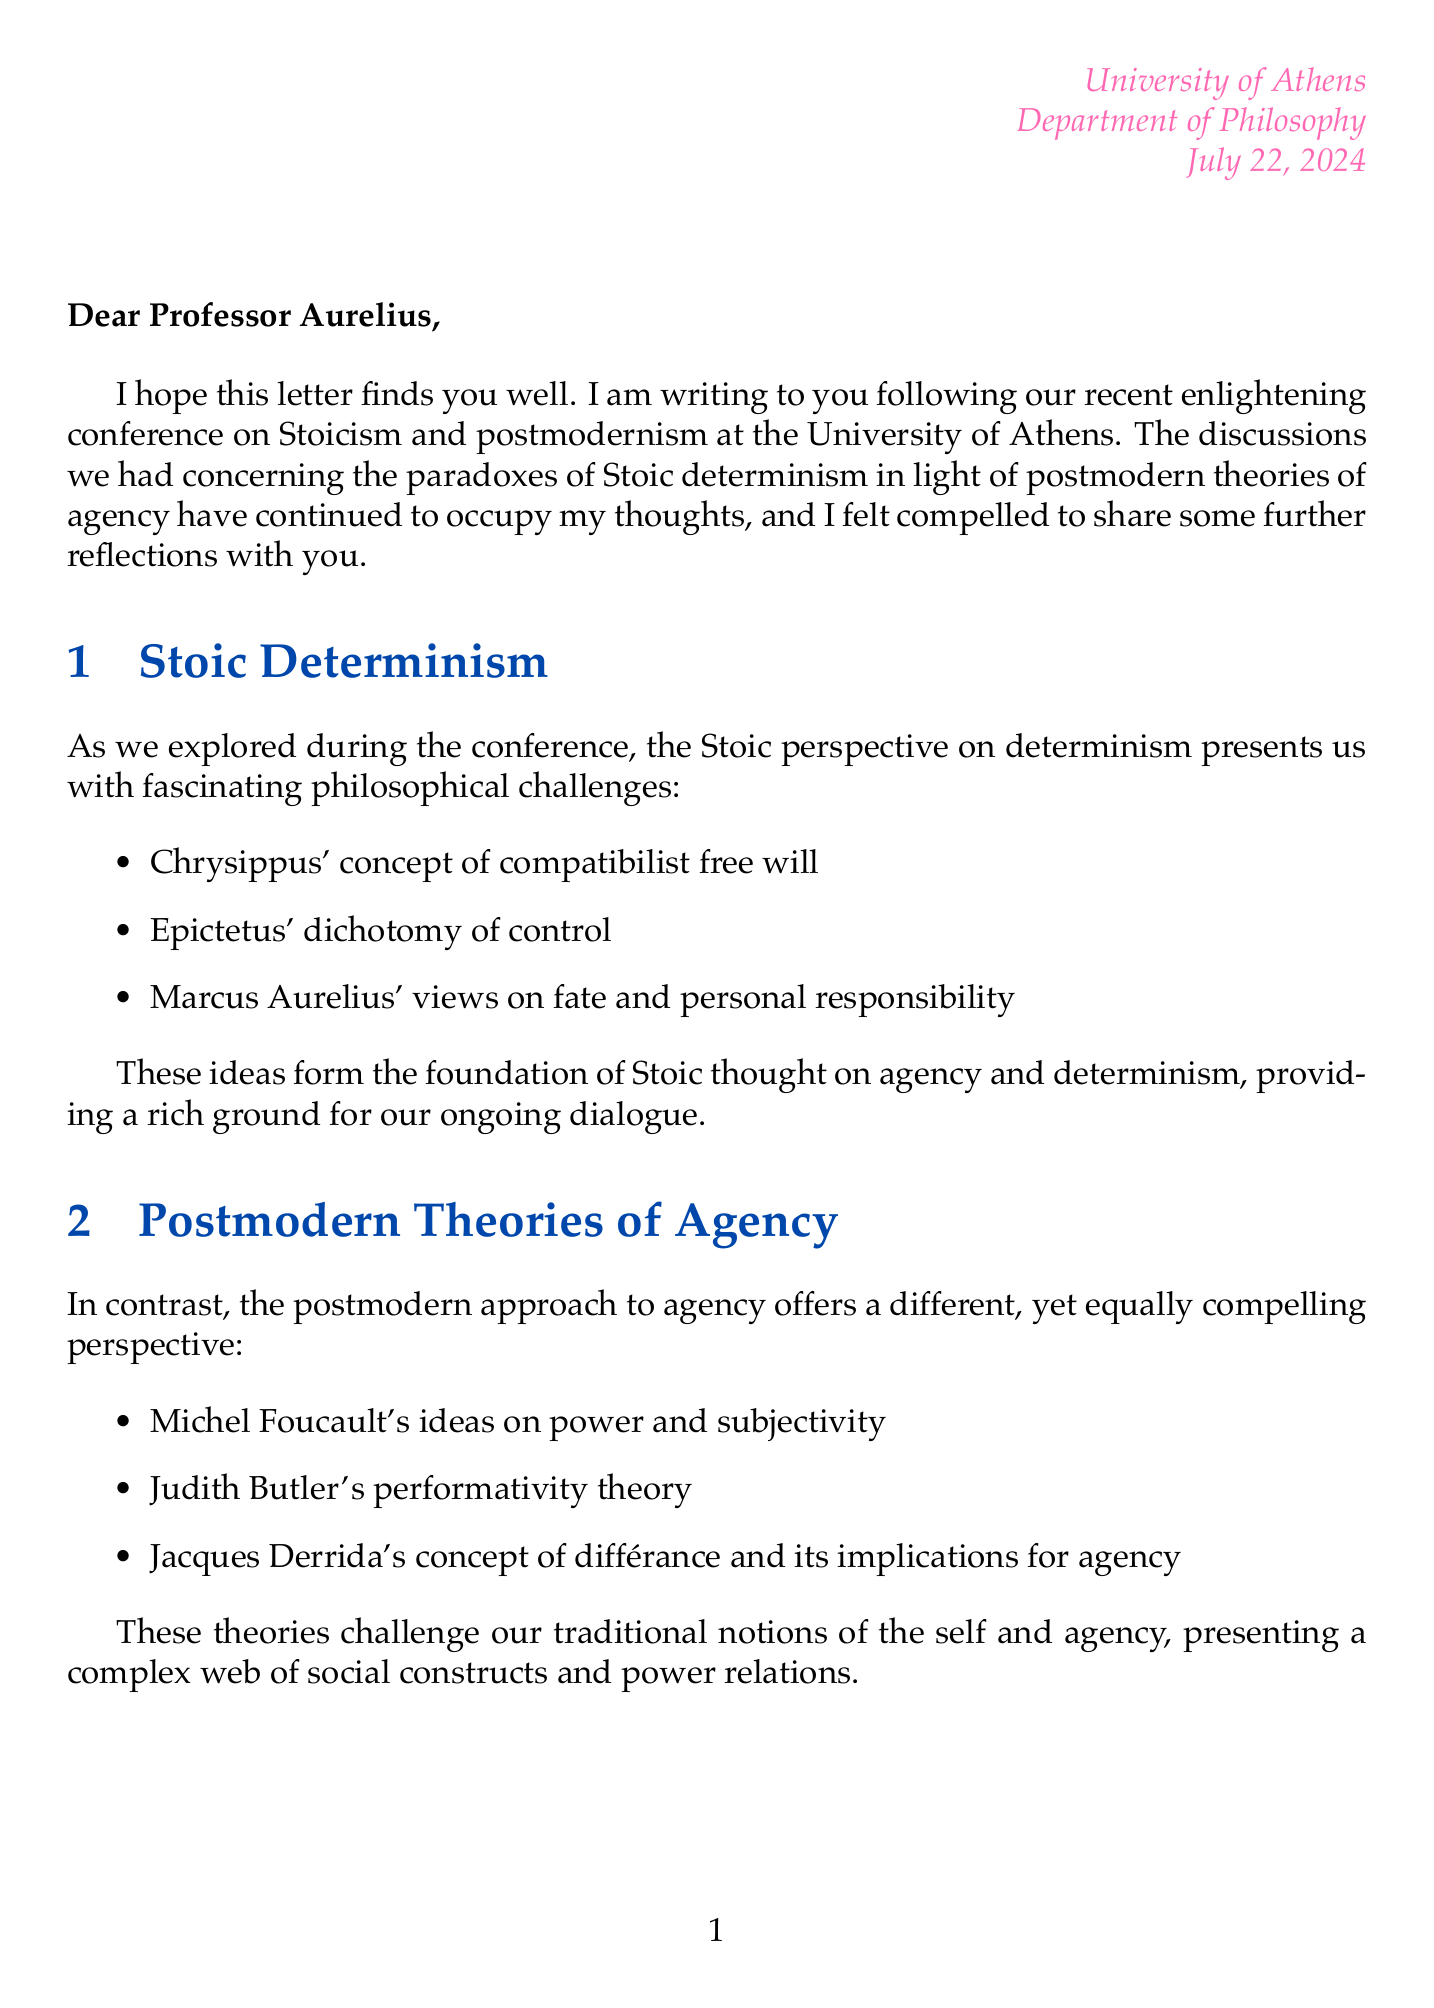What is the name of the letter's author? The author of the letter is Dr. Simone de Beauvoir, as stated in the closing section.
Answer: Dr. Simone de Beauvoir Where was the conference held? The letter mentions that the conference took place at the University of Athens.
Answer: University of Athens Which philosopher's concept relates to compatibilist free will? The letter references Chrysippus' concept, which is specifically tied to the idea of compatibilist free will.
Answer: Chrysippus What postmodern theorist is associated with performativity? Judith Butler is mentioned as the theorist associated with performativity theory in the document.
Answer: Judith Butler What is the conclusion's primary focus? The conclusion synthesizes Stoic and postmodern ideas on agency, as highlighted in that section.
Answer: Synthesis of Stoic and postmodern ideas on agency Which contemporary philosopher critiques both Stoicism and postmodernism? Slavoj Žižek is identified as the contemporary philosopher who critiques both philosophical traditions.
Answer: Slavoj Žižek What ethical approach does Martha Nussbaum take? The letter describes Martha Nussbaum's approach as neo-Stoic.
Answer: Neo-Stoic What philosophical theme does the letter explore? The letter explores the paradoxes of Stoic determinism in relation to postmodern theories of agency.
Answer: Paradoxes of Stoic determinism Which quote is attributed to Epictetus? The letter includes the quote about identifying matters of control, which is attributed to Epictetus.
Answer: "The chief task in life is simply this: to identify and separate matters so that I can say clearly to myself which are externals not under my control, and which have to do with the choices I actually control." 